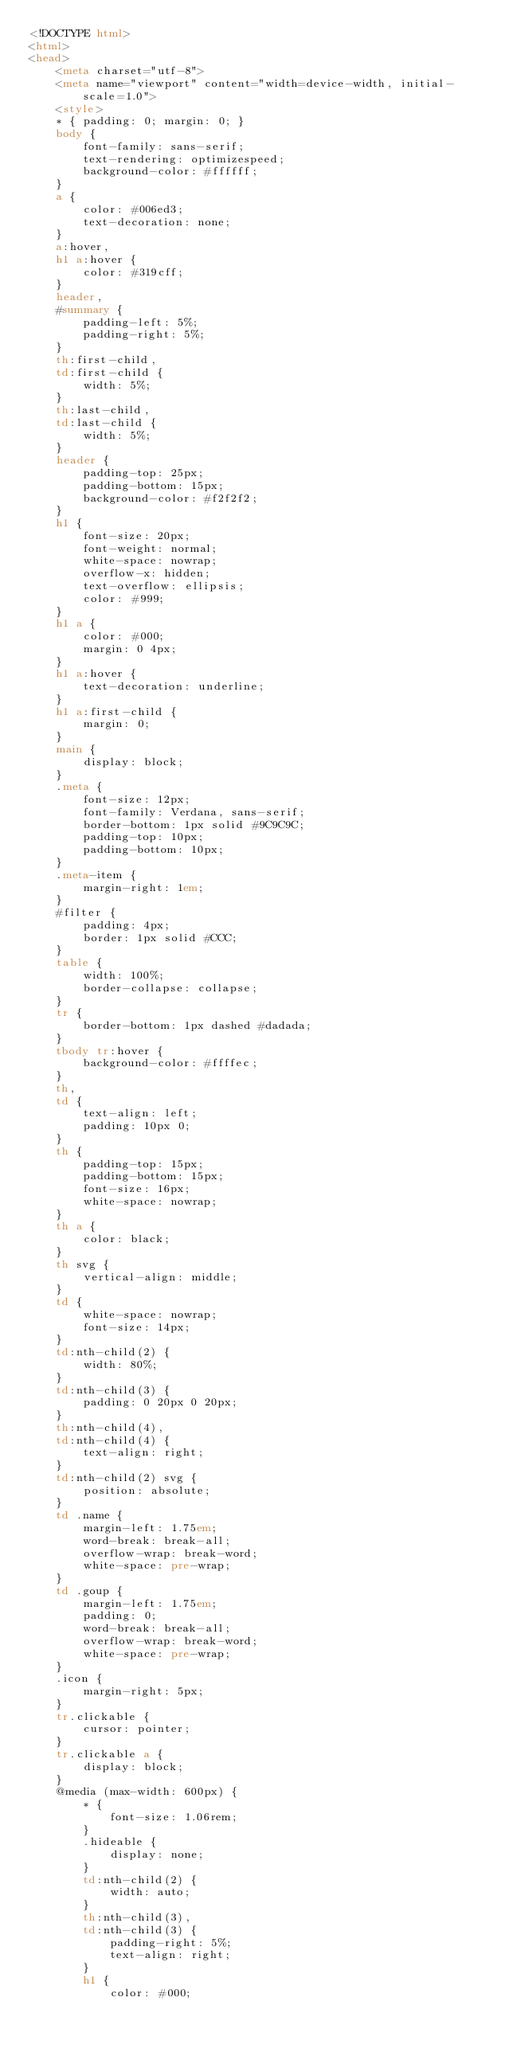<code> <loc_0><loc_0><loc_500><loc_500><_HTML_><!DOCTYPE html>
<html>
<head>
    <meta charset="utf-8">
    <meta name="viewport" content="width=device-width, initial-scale=1.0">
    <style>
    * { padding: 0; margin: 0; }
    body {
        font-family: sans-serif;
        text-rendering: optimizespeed;
        background-color: #ffffff;
    }
    a {
        color: #006ed3;
        text-decoration: none;
    }
    a:hover,
    h1 a:hover {
        color: #319cff;
    }
    header,
    #summary {
        padding-left: 5%;
        padding-right: 5%;
    }
    th:first-child,
    td:first-child {
        width: 5%;
    }
    th:last-child,
    td:last-child {
        width: 5%;
    }
    header {
        padding-top: 25px;
        padding-bottom: 15px;
        background-color: #f2f2f2;
    }
    h1 {
        font-size: 20px;
        font-weight: normal;
        white-space: nowrap;
        overflow-x: hidden;
        text-overflow: ellipsis;
        color: #999;
    }
    h1 a {
        color: #000;
        margin: 0 4px;
    }
    h1 a:hover {
        text-decoration: underline;
    }
    h1 a:first-child {
        margin: 0;
    }
    main {
        display: block;
    }
    .meta {
        font-size: 12px;
        font-family: Verdana, sans-serif;
        border-bottom: 1px solid #9C9C9C;
        padding-top: 10px;
        padding-bottom: 10px;
    }
    .meta-item {
        margin-right: 1em;
    }
    #filter {
        padding: 4px;
        border: 1px solid #CCC;
    }
    table {
        width: 100%;
        border-collapse: collapse;
    }
    tr {
        border-bottom: 1px dashed #dadada;
    }
    tbody tr:hover {
        background-color: #ffffec;
    }
    th,
    td {
        text-align: left;
        padding: 10px 0;
    }
    th {
        padding-top: 15px;
        padding-bottom: 15px;
        font-size: 16px;
        white-space: nowrap;
    }
    th a {
        color: black;
    }
    th svg {
        vertical-align: middle;
    }
    td {
        white-space: nowrap;
        font-size: 14px;
    }
    td:nth-child(2) {
        width: 80%;
    }
    td:nth-child(3) {
        padding: 0 20px 0 20px;
    }
    th:nth-child(4),
    td:nth-child(4) {
        text-align: right;
    }
    td:nth-child(2) svg {
        position: absolute;
    }
    td .name {
        margin-left: 1.75em;
        word-break: break-all;
        overflow-wrap: break-word;
        white-space: pre-wrap;
    }
    td .goup {
        margin-left: 1.75em;
        padding: 0;
        word-break: break-all;
        overflow-wrap: break-word;
        white-space: pre-wrap;
    }
    .icon {
        margin-right: 5px;
    }
    tr.clickable { 
        cursor: pointer; 
    } 
    tr.clickable a { 
        display: block; 
    } 
    @media (max-width: 600px) {
        * {
            font-size: 1.06rem;
        }
        .hideable {
            display: none;
        }
        td:nth-child(2) {
            width: auto;
        }
        th:nth-child(3),
        td:nth-child(3) {
            padding-right: 5%;
            text-align: right;
        }
        h1 {
            color: #000;</code> 